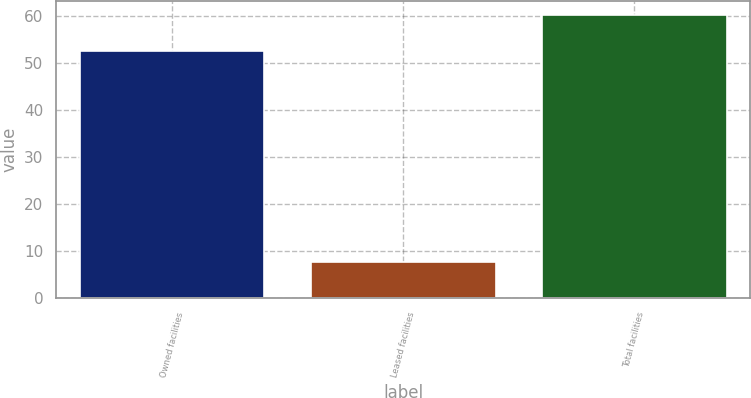Convert chart. <chart><loc_0><loc_0><loc_500><loc_500><bar_chart><fcel>Owned facilities<fcel>Leased facilities<fcel>Total facilities<nl><fcel>52.7<fcel>7.6<fcel>60.3<nl></chart> 